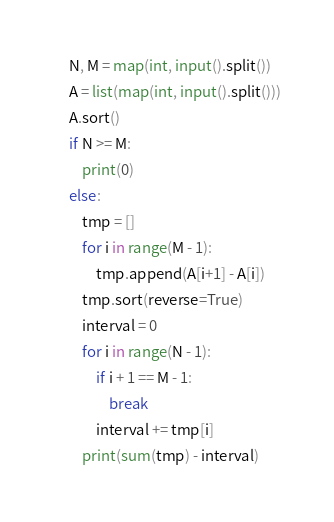Convert code to text. <code><loc_0><loc_0><loc_500><loc_500><_Python_>N, M = map(int, input().split())
A = list(map(int, input().split()))
A.sort()
if N >= M:
    print(0)
else:
    tmp = []
    for i in range(M - 1):
        tmp.append(A[i+1] - A[i])
    tmp.sort(reverse=True)
    interval = 0
    for i in range(N - 1):
        if i + 1 == M - 1:
            break
        interval += tmp[i]
    print(sum(tmp) - interval)</code> 